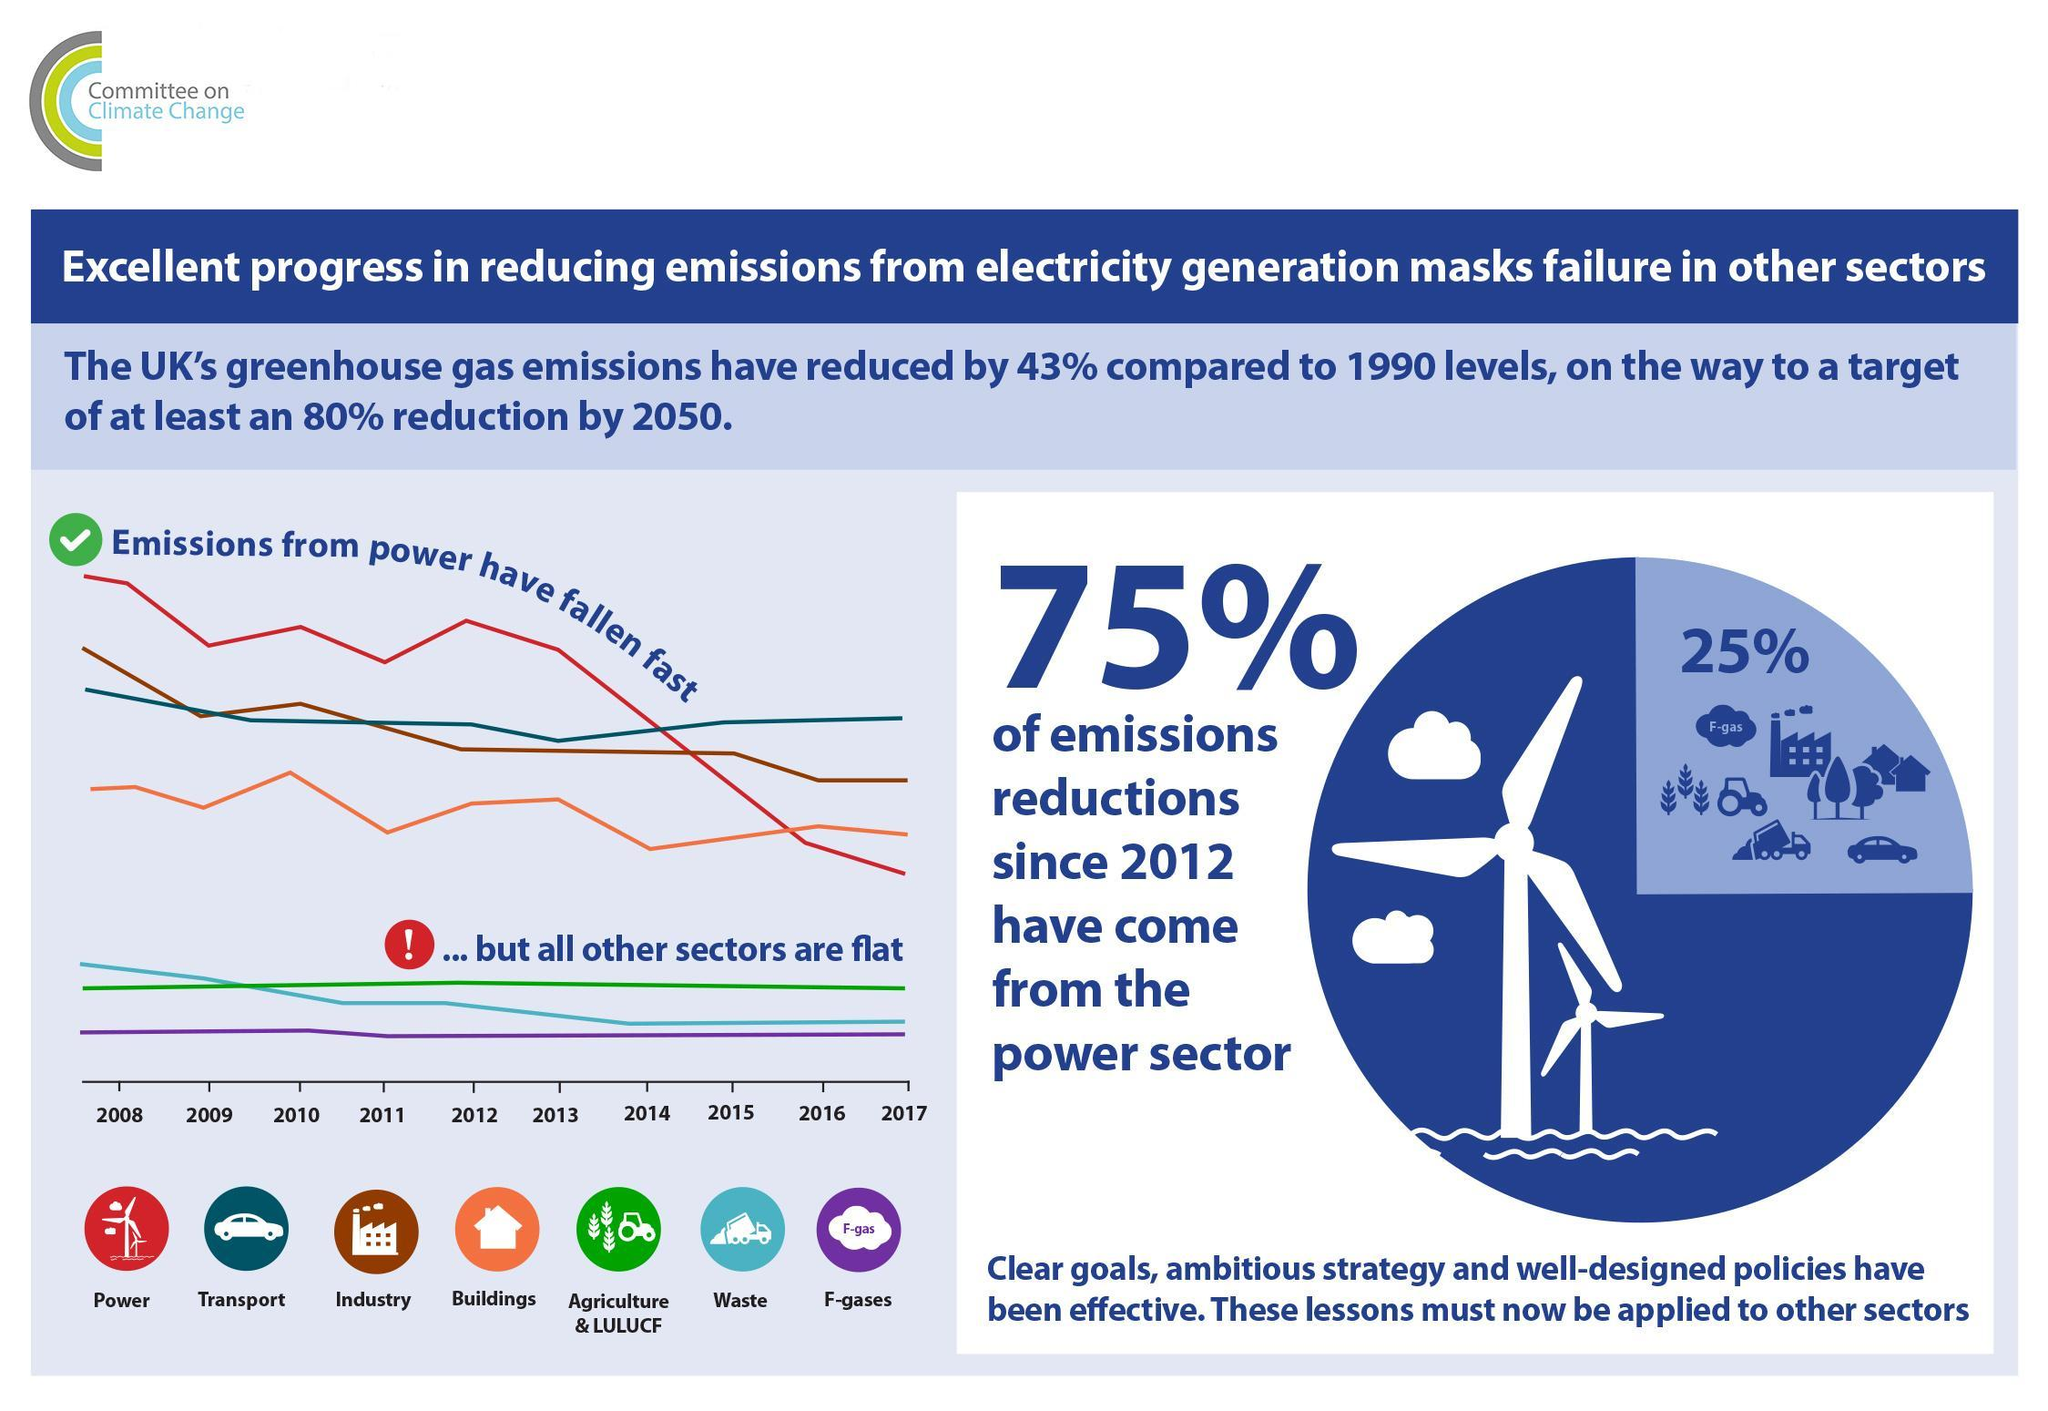Which sector contributed the most in reduction of emissions since 2012?
Answer the question with a short phrase. power sector 